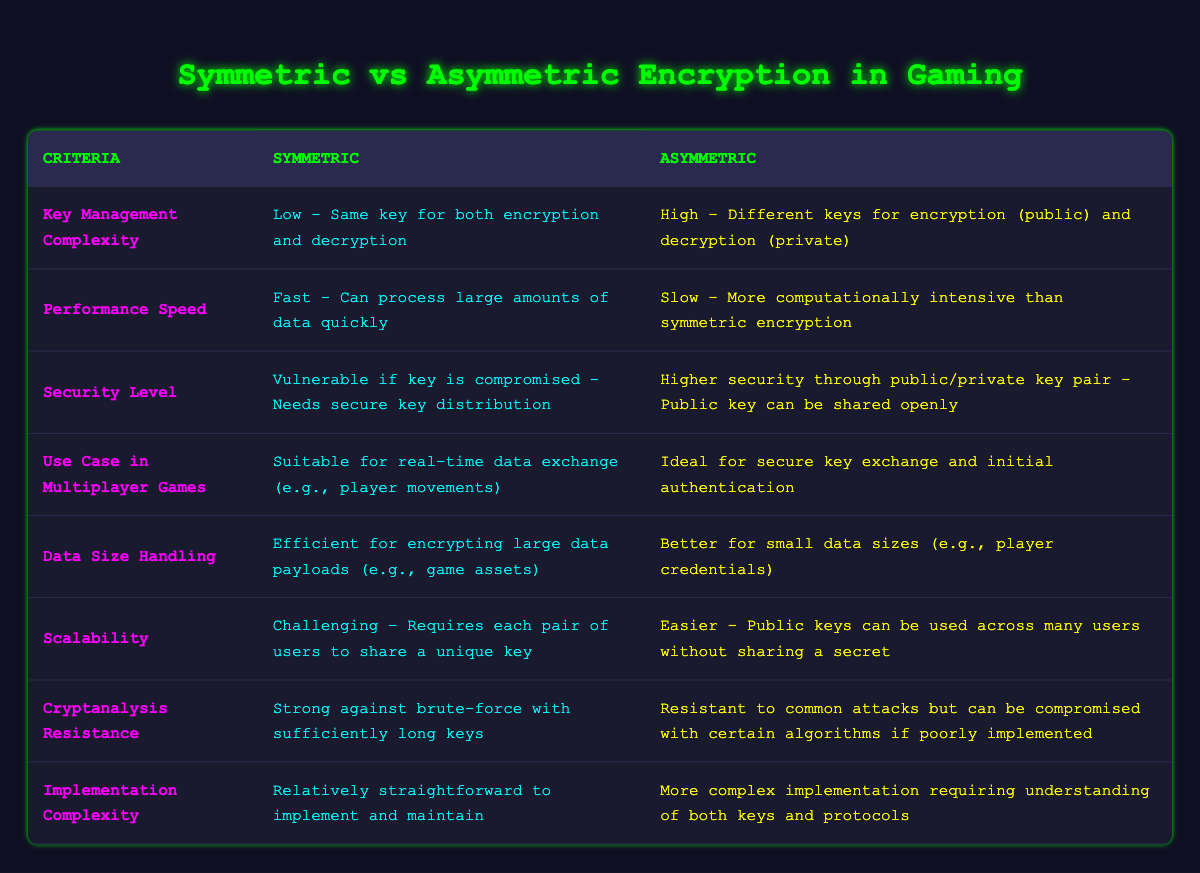What is the performance speed of symmetric encryption? According to the table, the performance speed for symmetric encryption is listed as 'Fast - Can process large amounts of data quickly'.
Answer: Fast Is asymmetric encryption suitable for real-time data exchange in multiplayer games? The table indicates that asymmetric encryption is 'Ideal for secure key exchange and initial authentication', which suggests it is not suitable for real-time data exchange.
Answer: No Which type of encryption has lower key management complexity? The table shows that symmetric encryption has a 'Low - Same key for both encryption and decryption', whereas asymmetric encryption has a 'High - Different keys for encryption (public) and decryption (private)'. Therefore, symmetric encryption has lower complexity.
Answer: Symmetric How does the data size handling efficiency compare between symmetric and asymmetric encryption? The table states that symmetric encryption is 'Efficient for encrypting large data payloads (e.g., game assets)', meanwhile, asymmetric encryption is 'Better for small data sizes (e.g., player credentials)'. For larger data, symmetric is preferred.
Answer: Symmetric If a game requires secure key exchange, which type of encryption should be used? The table indicates that asymmetric encryption is 'Ideal for secure key exchange and initial authentication', making it the suitable choice for secure key exchange.
Answer: Asymmetric What is a significant vulnerability of symmetric encryption? The table states that symmetric encryption is 'Vulnerable if key is compromised - Needs secure key distribution', highlighting this vulnerability.
Answer: Key vulnerability Which type of encryption is easier for scalability? According to the table, asymmetric encryption is 'Easier - Public keys can be used across many users without sharing a secret', meaning it is better for scalability compared to symmetric encryption.
Answer: Asymmetric What is the implementation complexity of symmetric encryption compared to asymmetric encryption? The table notes that symmetric encryption is 'Relatively straightforward to implement and maintain', while asymmetric encryption is 'More complex implementation requiring understanding of both keys and protocols'. This comparison indicates symmetric is less complex.
Answer: Symmetric What common attack resistance difference exists between symmetric and asymmetric encryption? The table states that symmetric is 'Strong against brute-force with sufficiently long keys', while asymmetric encryption is 'Resistant to common attacks but can be compromised with certain algorithms if poorly implemented'. This indicates asymmetric has certain vulnerabilities.
Answer: Asymmetric 